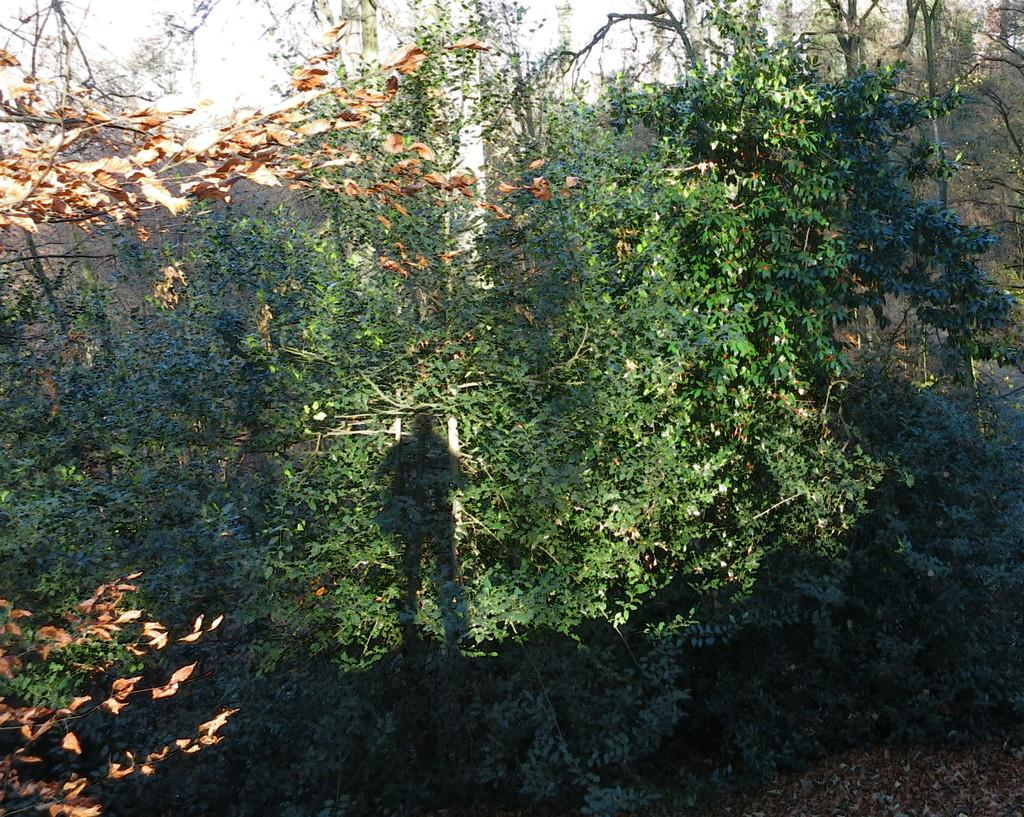What type of vegetation can be seen in the image? There are many plants on the ground in the image. What structure is visible at the top of the image? There is a wall visible at the top of the image. What type of bucket is being used to guide the plants in the image? There is no bucket or guiding mechanism present in the image; it simply shows plants on the ground and a wall at the top. 